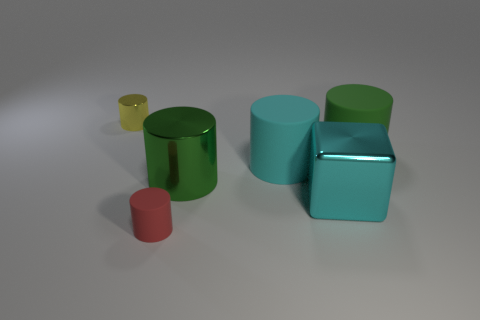There is a object that is the same color as the large block; what is its size?
Give a very brief answer. Large. The big metal cylinder is what color?
Offer a terse response. Green. What is the color of the shiny thing that is to the left of the large cyan rubber cylinder and in front of the tiny yellow shiny thing?
Provide a short and direct response. Green. What is the color of the small cylinder that is on the left side of the tiny thing that is right of the tiny cylinder that is behind the red rubber object?
Offer a terse response. Yellow. There is a metal object that is the same size as the red cylinder; what is its color?
Ensure brevity in your answer.  Yellow. The large cyan metal object in front of the tiny cylinder to the left of the tiny object that is in front of the small shiny cylinder is what shape?
Make the answer very short. Cube. There is a big rubber thing that is the same color as the cube; what is its shape?
Ensure brevity in your answer.  Cylinder. How many things are either red rubber things or shiny cylinders right of the tiny rubber cylinder?
Provide a succinct answer. 2. There is a metal cylinder that is right of the red matte object; is its size the same as the tiny red matte object?
Ensure brevity in your answer.  No. What is the large cyan thing in front of the big cyan rubber object made of?
Offer a very short reply. Metal. 